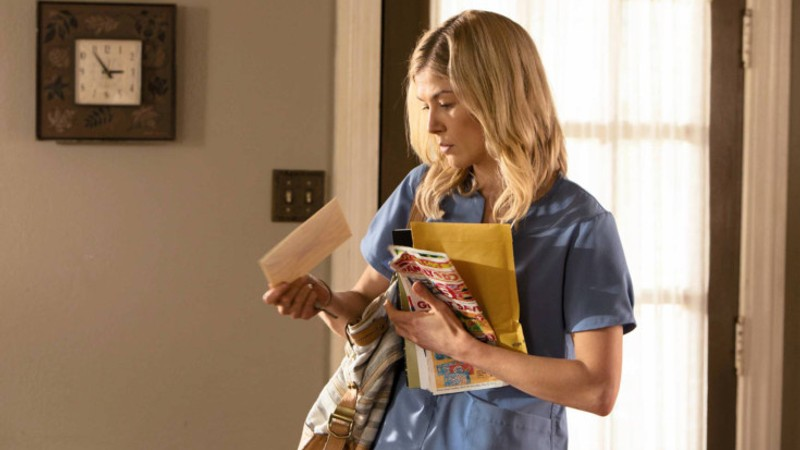Can you elaborate on the setting of this image? The setting appears to be an indoor environment with elements typical of a residential space. The presence of a plain wall clock and window with blinds suggests a functional, unadorned area, possibly a space used for professional purposes like patient consultations within a home setting or a small health clinic. The uncluttered background focuses attention on the main subject and her activities. 